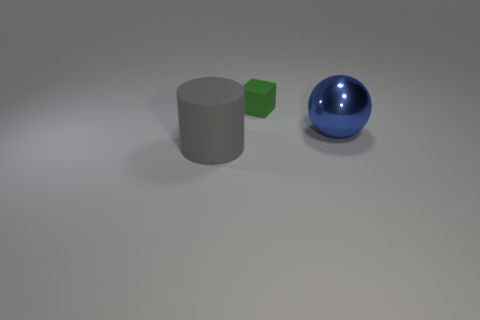Is the size of the metallic ball the same as the object in front of the blue shiny object?
Offer a very short reply. Yes. How many things are either shiny spheres that are right of the tiny green matte object or big blue things that are in front of the matte block?
Your answer should be very brief. 1. What shape is the other thing that is the same size as the blue thing?
Keep it short and to the point. Cylinder. There is a matte thing right of the rubber object that is on the left side of the rubber thing to the right of the gray matte thing; what is its shape?
Your response must be concise. Cube. Is the number of green matte things behind the large blue object the same as the number of large blue rubber spheres?
Offer a very short reply. No. Is the size of the blue thing the same as the gray cylinder?
Offer a very short reply. Yes. How many matte things are tiny cyan cylinders or blocks?
Your response must be concise. 1. There is a blue thing that is the same size as the gray rubber thing; what is its material?
Your answer should be compact. Metal. How many other things are made of the same material as the large blue object?
Make the answer very short. 0. Is the number of cylinders right of the big matte object less than the number of big purple cylinders?
Give a very brief answer. No. 